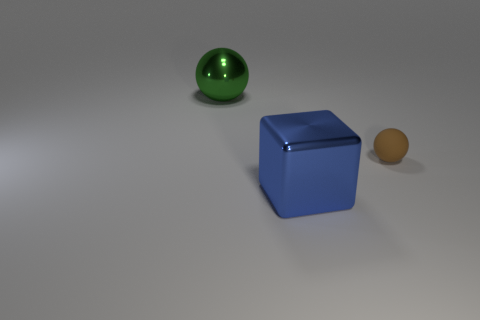There is a large blue metallic object; what shape is it?
Keep it short and to the point. Cube. There is a small ball; how many big spheres are to the right of it?
Provide a succinct answer. 0. How many large green things are the same material as the blue block?
Your answer should be very brief. 1. Are the blue block left of the brown sphere and the brown sphere made of the same material?
Provide a succinct answer. No. Are there any metallic things?
Your response must be concise. Yes. What size is the object that is both in front of the green sphere and left of the small brown matte ball?
Provide a succinct answer. Large. Is the number of rubber things that are behind the large green metallic sphere greater than the number of tiny rubber things that are in front of the tiny sphere?
Keep it short and to the point. No. The big sphere is what color?
Provide a short and direct response. Green. There is a thing that is on the left side of the tiny sphere and behind the blue thing; what is its color?
Your answer should be compact. Green. The metallic thing behind the sphere that is to the right of the large metallic thing that is in front of the big metallic ball is what color?
Your answer should be very brief. Green. 